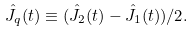<formula> <loc_0><loc_0><loc_500><loc_500>\hat { J } _ { q } ( t ) \equiv ( \hat { J } _ { 2 } ( t ) - \hat { J } _ { 1 } ( t ) ) / 2 .</formula> 